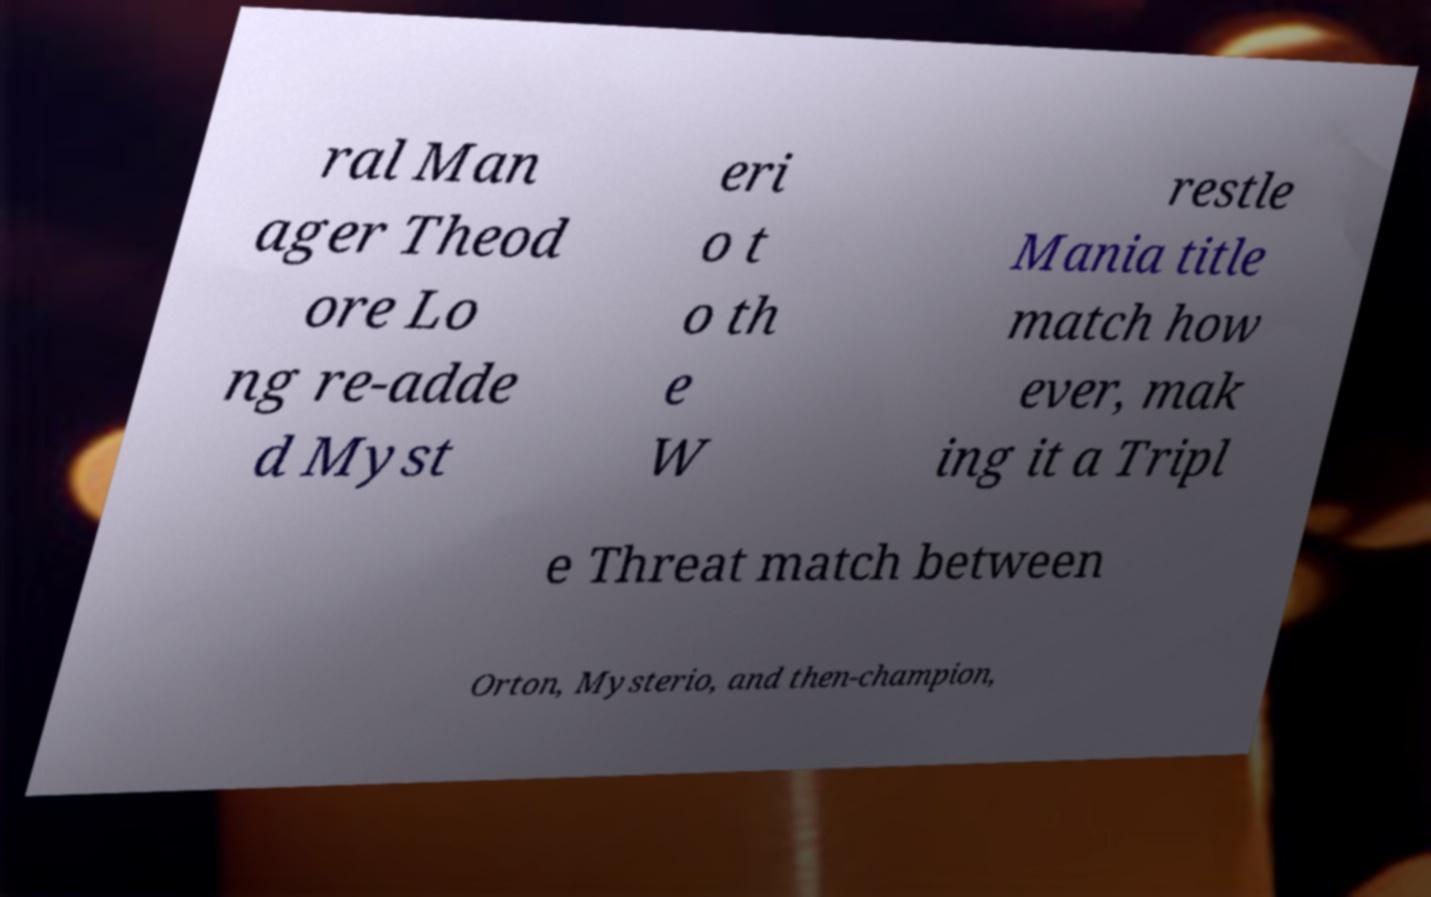Please identify and transcribe the text found in this image. ral Man ager Theod ore Lo ng re-adde d Myst eri o t o th e W restle Mania title match how ever, mak ing it a Tripl e Threat match between Orton, Mysterio, and then-champion, 